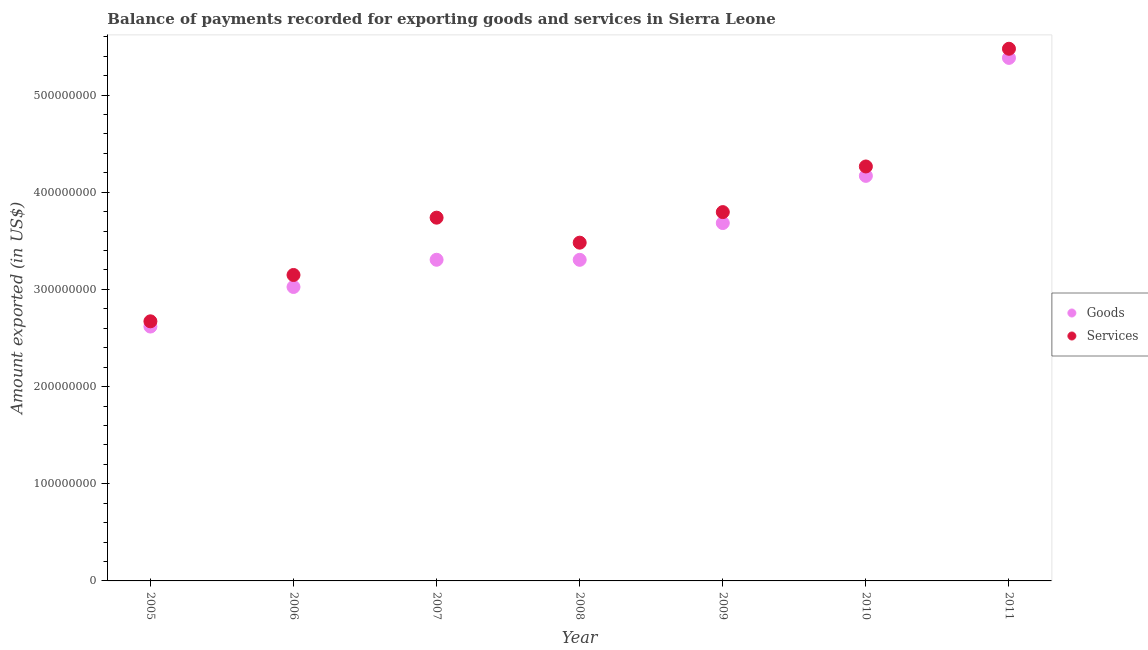What is the amount of services exported in 2011?
Your answer should be compact. 5.48e+08. Across all years, what is the maximum amount of services exported?
Offer a very short reply. 5.48e+08. Across all years, what is the minimum amount of services exported?
Provide a succinct answer. 2.67e+08. In which year was the amount of goods exported maximum?
Give a very brief answer. 2011. What is the total amount of services exported in the graph?
Your answer should be very brief. 2.66e+09. What is the difference between the amount of services exported in 2010 and that in 2011?
Make the answer very short. -1.21e+08. What is the difference between the amount of services exported in 2007 and the amount of goods exported in 2008?
Your answer should be compact. 4.34e+07. What is the average amount of services exported per year?
Provide a succinct answer. 3.80e+08. In the year 2006, what is the difference between the amount of goods exported and amount of services exported?
Make the answer very short. -1.23e+07. What is the ratio of the amount of services exported in 2005 to that in 2008?
Your response must be concise. 0.77. What is the difference between the highest and the second highest amount of goods exported?
Give a very brief answer. 1.21e+08. What is the difference between the highest and the lowest amount of services exported?
Provide a succinct answer. 2.80e+08. How many dotlines are there?
Give a very brief answer. 2. How many years are there in the graph?
Keep it short and to the point. 7. What is the difference between two consecutive major ticks on the Y-axis?
Offer a terse response. 1.00e+08. Are the values on the major ticks of Y-axis written in scientific E-notation?
Provide a short and direct response. No. Does the graph contain any zero values?
Provide a succinct answer. No. Where does the legend appear in the graph?
Your answer should be very brief. Center right. How many legend labels are there?
Give a very brief answer. 2. How are the legend labels stacked?
Your answer should be very brief. Vertical. What is the title of the graph?
Offer a terse response. Balance of payments recorded for exporting goods and services in Sierra Leone. What is the label or title of the Y-axis?
Provide a succinct answer. Amount exported (in US$). What is the Amount exported (in US$) in Goods in 2005?
Your response must be concise. 2.62e+08. What is the Amount exported (in US$) of Services in 2005?
Your answer should be compact. 2.67e+08. What is the Amount exported (in US$) in Goods in 2006?
Your response must be concise. 3.03e+08. What is the Amount exported (in US$) of Services in 2006?
Your answer should be very brief. 3.15e+08. What is the Amount exported (in US$) of Goods in 2007?
Provide a succinct answer. 3.31e+08. What is the Amount exported (in US$) of Services in 2007?
Offer a very short reply. 3.74e+08. What is the Amount exported (in US$) of Goods in 2008?
Offer a terse response. 3.30e+08. What is the Amount exported (in US$) in Services in 2008?
Offer a terse response. 3.48e+08. What is the Amount exported (in US$) in Goods in 2009?
Your answer should be compact. 3.68e+08. What is the Amount exported (in US$) of Services in 2009?
Provide a succinct answer. 3.80e+08. What is the Amount exported (in US$) of Goods in 2010?
Provide a short and direct response. 4.17e+08. What is the Amount exported (in US$) in Services in 2010?
Your answer should be very brief. 4.27e+08. What is the Amount exported (in US$) of Goods in 2011?
Make the answer very short. 5.38e+08. What is the Amount exported (in US$) in Services in 2011?
Ensure brevity in your answer.  5.48e+08. Across all years, what is the maximum Amount exported (in US$) of Goods?
Offer a very short reply. 5.38e+08. Across all years, what is the maximum Amount exported (in US$) in Services?
Offer a very short reply. 5.48e+08. Across all years, what is the minimum Amount exported (in US$) in Goods?
Ensure brevity in your answer.  2.62e+08. Across all years, what is the minimum Amount exported (in US$) of Services?
Provide a succinct answer. 2.67e+08. What is the total Amount exported (in US$) of Goods in the graph?
Offer a terse response. 2.55e+09. What is the total Amount exported (in US$) in Services in the graph?
Keep it short and to the point. 2.66e+09. What is the difference between the Amount exported (in US$) in Goods in 2005 and that in 2006?
Offer a very short reply. -4.07e+07. What is the difference between the Amount exported (in US$) in Services in 2005 and that in 2006?
Your response must be concise. -4.77e+07. What is the difference between the Amount exported (in US$) in Goods in 2005 and that in 2007?
Provide a short and direct response. -6.87e+07. What is the difference between the Amount exported (in US$) of Services in 2005 and that in 2007?
Offer a terse response. -1.07e+08. What is the difference between the Amount exported (in US$) in Goods in 2005 and that in 2008?
Ensure brevity in your answer.  -6.87e+07. What is the difference between the Amount exported (in US$) in Services in 2005 and that in 2008?
Keep it short and to the point. -8.09e+07. What is the difference between the Amount exported (in US$) of Goods in 2005 and that in 2009?
Offer a terse response. -1.07e+08. What is the difference between the Amount exported (in US$) of Services in 2005 and that in 2009?
Provide a succinct answer. -1.12e+08. What is the difference between the Amount exported (in US$) of Goods in 2005 and that in 2010?
Ensure brevity in your answer.  -1.55e+08. What is the difference between the Amount exported (in US$) in Services in 2005 and that in 2010?
Offer a terse response. -1.59e+08. What is the difference between the Amount exported (in US$) of Goods in 2005 and that in 2011?
Keep it short and to the point. -2.76e+08. What is the difference between the Amount exported (in US$) in Services in 2005 and that in 2011?
Give a very brief answer. -2.80e+08. What is the difference between the Amount exported (in US$) in Goods in 2006 and that in 2007?
Offer a terse response. -2.80e+07. What is the difference between the Amount exported (in US$) in Services in 2006 and that in 2007?
Provide a succinct answer. -5.90e+07. What is the difference between the Amount exported (in US$) in Goods in 2006 and that in 2008?
Keep it short and to the point. -2.79e+07. What is the difference between the Amount exported (in US$) in Services in 2006 and that in 2008?
Ensure brevity in your answer.  -3.33e+07. What is the difference between the Amount exported (in US$) in Goods in 2006 and that in 2009?
Ensure brevity in your answer.  -6.58e+07. What is the difference between the Amount exported (in US$) of Services in 2006 and that in 2009?
Ensure brevity in your answer.  -6.47e+07. What is the difference between the Amount exported (in US$) of Goods in 2006 and that in 2010?
Make the answer very short. -1.14e+08. What is the difference between the Amount exported (in US$) in Services in 2006 and that in 2010?
Ensure brevity in your answer.  -1.12e+08. What is the difference between the Amount exported (in US$) of Goods in 2006 and that in 2011?
Your answer should be very brief. -2.36e+08. What is the difference between the Amount exported (in US$) of Services in 2006 and that in 2011?
Give a very brief answer. -2.33e+08. What is the difference between the Amount exported (in US$) of Goods in 2007 and that in 2008?
Ensure brevity in your answer.  5.84e+04. What is the difference between the Amount exported (in US$) in Services in 2007 and that in 2008?
Your response must be concise. 2.57e+07. What is the difference between the Amount exported (in US$) in Goods in 2007 and that in 2009?
Your response must be concise. -3.78e+07. What is the difference between the Amount exported (in US$) in Services in 2007 and that in 2009?
Provide a short and direct response. -5.72e+06. What is the difference between the Amount exported (in US$) in Goods in 2007 and that in 2010?
Your response must be concise. -8.63e+07. What is the difference between the Amount exported (in US$) in Services in 2007 and that in 2010?
Your response must be concise. -5.27e+07. What is the difference between the Amount exported (in US$) of Goods in 2007 and that in 2011?
Your answer should be compact. -2.08e+08. What is the difference between the Amount exported (in US$) in Services in 2007 and that in 2011?
Keep it short and to the point. -1.74e+08. What is the difference between the Amount exported (in US$) in Goods in 2008 and that in 2009?
Your response must be concise. -3.79e+07. What is the difference between the Amount exported (in US$) of Services in 2008 and that in 2009?
Give a very brief answer. -3.15e+07. What is the difference between the Amount exported (in US$) of Goods in 2008 and that in 2010?
Ensure brevity in your answer.  -8.64e+07. What is the difference between the Amount exported (in US$) of Services in 2008 and that in 2010?
Your answer should be compact. -7.84e+07. What is the difference between the Amount exported (in US$) in Goods in 2008 and that in 2011?
Your response must be concise. -2.08e+08. What is the difference between the Amount exported (in US$) of Services in 2008 and that in 2011?
Keep it short and to the point. -2.00e+08. What is the difference between the Amount exported (in US$) in Goods in 2009 and that in 2010?
Your answer should be compact. -4.86e+07. What is the difference between the Amount exported (in US$) of Services in 2009 and that in 2010?
Offer a terse response. -4.70e+07. What is the difference between the Amount exported (in US$) of Goods in 2009 and that in 2011?
Give a very brief answer. -1.70e+08. What is the difference between the Amount exported (in US$) in Services in 2009 and that in 2011?
Your answer should be compact. -1.68e+08. What is the difference between the Amount exported (in US$) of Goods in 2010 and that in 2011?
Offer a terse response. -1.21e+08. What is the difference between the Amount exported (in US$) of Services in 2010 and that in 2011?
Give a very brief answer. -1.21e+08. What is the difference between the Amount exported (in US$) of Goods in 2005 and the Amount exported (in US$) of Services in 2006?
Your answer should be very brief. -5.31e+07. What is the difference between the Amount exported (in US$) in Goods in 2005 and the Amount exported (in US$) in Services in 2007?
Keep it short and to the point. -1.12e+08. What is the difference between the Amount exported (in US$) in Goods in 2005 and the Amount exported (in US$) in Services in 2008?
Offer a very short reply. -8.63e+07. What is the difference between the Amount exported (in US$) of Goods in 2005 and the Amount exported (in US$) of Services in 2009?
Your response must be concise. -1.18e+08. What is the difference between the Amount exported (in US$) of Goods in 2005 and the Amount exported (in US$) of Services in 2010?
Provide a short and direct response. -1.65e+08. What is the difference between the Amount exported (in US$) in Goods in 2005 and the Amount exported (in US$) in Services in 2011?
Ensure brevity in your answer.  -2.86e+08. What is the difference between the Amount exported (in US$) in Goods in 2006 and the Amount exported (in US$) in Services in 2007?
Your response must be concise. -7.13e+07. What is the difference between the Amount exported (in US$) of Goods in 2006 and the Amount exported (in US$) of Services in 2008?
Make the answer very short. -4.56e+07. What is the difference between the Amount exported (in US$) of Goods in 2006 and the Amount exported (in US$) of Services in 2009?
Keep it short and to the point. -7.70e+07. What is the difference between the Amount exported (in US$) in Goods in 2006 and the Amount exported (in US$) in Services in 2010?
Make the answer very short. -1.24e+08. What is the difference between the Amount exported (in US$) of Goods in 2006 and the Amount exported (in US$) of Services in 2011?
Make the answer very short. -2.45e+08. What is the difference between the Amount exported (in US$) of Goods in 2007 and the Amount exported (in US$) of Services in 2008?
Offer a very short reply. -1.76e+07. What is the difference between the Amount exported (in US$) in Goods in 2007 and the Amount exported (in US$) in Services in 2009?
Keep it short and to the point. -4.90e+07. What is the difference between the Amount exported (in US$) of Goods in 2007 and the Amount exported (in US$) of Services in 2010?
Provide a succinct answer. -9.60e+07. What is the difference between the Amount exported (in US$) in Goods in 2007 and the Amount exported (in US$) in Services in 2011?
Your answer should be compact. -2.17e+08. What is the difference between the Amount exported (in US$) in Goods in 2008 and the Amount exported (in US$) in Services in 2009?
Ensure brevity in your answer.  -4.91e+07. What is the difference between the Amount exported (in US$) of Goods in 2008 and the Amount exported (in US$) of Services in 2010?
Your answer should be compact. -9.61e+07. What is the difference between the Amount exported (in US$) in Goods in 2008 and the Amount exported (in US$) in Services in 2011?
Offer a terse response. -2.17e+08. What is the difference between the Amount exported (in US$) of Goods in 2009 and the Amount exported (in US$) of Services in 2010?
Make the answer very short. -5.82e+07. What is the difference between the Amount exported (in US$) of Goods in 2009 and the Amount exported (in US$) of Services in 2011?
Your response must be concise. -1.79e+08. What is the difference between the Amount exported (in US$) in Goods in 2010 and the Amount exported (in US$) in Services in 2011?
Offer a terse response. -1.31e+08. What is the average Amount exported (in US$) of Goods per year?
Ensure brevity in your answer.  3.64e+08. What is the average Amount exported (in US$) of Services per year?
Ensure brevity in your answer.  3.80e+08. In the year 2005, what is the difference between the Amount exported (in US$) of Goods and Amount exported (in US$) of Services?
Your answer should be compact. -5.38e+06. In the year 2006, what is the difference between the Amount exported (in US$) in Goods and Amount exported (in US$) in Services?
Provide a short and direct response. -1.23e+07. In the year 2007, what is the difference between the Amount exported (in US$) in Goods and Amount exported (in US$) in Services?
Your answer should be compact. -4.33e+07. In the year 2008, what is the difference between the Amount exported (in US$) in Goods and Amount exported (in US$) in Services?
Make the answer very short. -1.77e+07. In the year 2009, what is the difference between the Amount exported (in US$) in Goods and Amount exported (in US$) in Services?
Your answer should be very brief. -1.13e+07. In the year 2010, what is the difference between the Amount exported (in US$) of Goods and Amount exported (in US$) of Services?
Your answer should be compact. -9.66e+06. In the year 2011, what is the difference between the Amount exported (in US$) in Goods and Amount exported (in US$) in Services?
Keep it short and to the point. -9.40e+06. What is the ratio of the Amount exported (in US$) of Goods in 2005 to that in 2006?
Provide a succinct answer. 0.87. What is the ratio of the Amount exported (in US$) in Services in 2005 to that in 2006?
Offer a very short reply. 0.85. What is the ratio of the Amount exported (in US$) of Goods in 2005 to that in 2007?
Keep it short and to the point. 0.79. What is the ratio of the Amount exported (in US$) in Services in 2005 to that in 2007?
Provide a succinct answer. 0.71. What is the ratio of the Amount exported (in US$) of Goods in 2005 to that in 2008?
Your response must be concise. 0.79. What is the ratio of the Amount exported (in US$) in Services in 2005 to that in 2008?
Keep it short and to the point. 0.77. What is the ratio of the Amount exported (in US$) in Goods in 2005 to that in 2009?
Your answer should be very brief. 0.71. What is the ratio of the Amount exported (in US$) in Services in 2005 to that in 2009?
Provide a short and direct response. 0.7. What is the ratio of the Amount exported (in US$) of Goods in 2005 to that in 2010?
Offer a very short reply. 0.63. What is the ratio of the Amount exported (in US$) in Services in 2005 to that in 2010?
Keep it short and to the point. 0.63. What is the ratio of the Amount exported (in US$) in Goods in 2005 to that in 2011?
Offer a terse response. 0.49. What is the ratio of the Amount exported (in US$) of Services in 2005 to that in 2011?
Ensure brevity in your answer.  0.49. What is the ratio of the Amount exported (in US$) of Goods in 2006 to that in 2007?
Offer a very short reply. 0.92. What is the ratio of the Amount exported (in US$) in Services in 2006 to that in 2007?
Your answer should be compact. 0.84. What is the ratio of the Amount exported (in US$) of Goods in 2006 to that in 2008?
Give a very brief answer. 0.92. What is the ratio of the Amount exported (in US$) of Services in 2006 to that in 2008?
Your response must be concise. 0.9. What is the ratio of the Amount exported (in US$) in Goods in 2006 to that in 2009?
Offer a very short reply. 0.82. What is the ratio of the Amount exported (in US$) of Services in 2006 to that in 2009?
Offer a terse response. 0.83. What is the ratio of the Amount exported (in US$) in Goods in 2006 to that in 2010?
Ensure brevity in your answer.  0.73. What is the ratio of the Amount exported (in US$) in Services in 2006 to that in 2010?
Provide a short and direct response. 0.74. What is the ratio of the Amount exported (in US$) in Goods in 2006 to that in 2011?
Give a very brief answer. 0.56. What is the ratio of the Amount exported (in US$) of Services in 2006 to that in 2011?
Give a very brief answer. 0.57. What is the ratio of the Amount exported (in US$) of Services in 2007 to that in 2008?
Ensure brevity in your answer.  1.07. What is the ratio of the Amount exported (in US$) of Goods in 2007 to that in 2009?
Give a very brief answer. 0.9. What is the ratio of the Amount exported (in US$) of Services in 2007 to that in 2009?
Your answer should be compact. 0.98. What is the ratio of the Amount exported (in US$) of Goods in 2007 to that in 2010?
Ensure brevity in your answer.  0.79. What is the ratio of the Amount exported (in US$) in Services in 2007 to that in 2010?
Your answer should be compact. 0.88. What is the ratio of the Amount exported (in US$) of Goods in 2007 to that in 2011?
Offer a very short reply. 0.61. What is the ratio of the Amount exported (in US$) of Services in 2007 to that in 2011?
Provide a short and direct response. 0.68. What is the ratio of the Amount exported (in US$) in Goods in 2008 to that in 2009?
Keep it short and to the point. 0.9. What is the ratio of the Amount exported (in US$) in Services in 2008 to that in 2009?
Your answer should be compact. 0.92. What is the ratio of the Amount exported (in US$) of Goods in 2008 to that in 2010?
Ensure brevity in your answer.  0.79. What is the ratio of the Amount exported (in US$) in Services in 2008 to that in 2010?
Offer a terse response. 0.82. What is the ratio of the Amount exported (in US$) in Goods in 2008 to that in 2011?
Offer a very short reply. 0.61. What is the ratio of the Amount exported (in US$) in Services in 2008 to that in 2011?
Provide a succinct answer. 0.64. What is the ratio of the Amount exported (in US$) in Goods in 2009 to that in 2010?
Your answer should be very brief. 0.88. What is the ratio of the Amount exported (in US$) of Services in 2009 to that in 2010?
Make the answer very short. 0.89. What is the ratio of the Amount exported (in US$) in Goods in 2009 to that in 2011?
Keep it short and to the point. 0.68. What is the ratio of the Amount exported (in US$) of Services in 2009 to that in 2011?
Your response must be concise. 0.69. What is the ratio of the Amount exported (in US$) of Goods in 2010 to that in 2011?
Your answer should be compact. 0.77. What is the ratio of the Amount exported (in US$) in Services in 2010 to that in 2011?
Keep it short and to the point. 0.78. What is the difference between the highest and the second highest Amount exported (in US$) in Goods?
Your answer should be compact. 1.21e+08. What is the difference between the highest and the second highest Amount exported (in US$) of Services?
Provide a short and direct response. 1.21e+08. What is the difference between the highest and the lowest Amount exported (in US$) of Goods?
Provide a succinct answer. 2.76e+08. What is the difference between the highest and the lowest Amount exported (in US$) in Services?
Ensure brevity in your answer.  2.80e+08. 